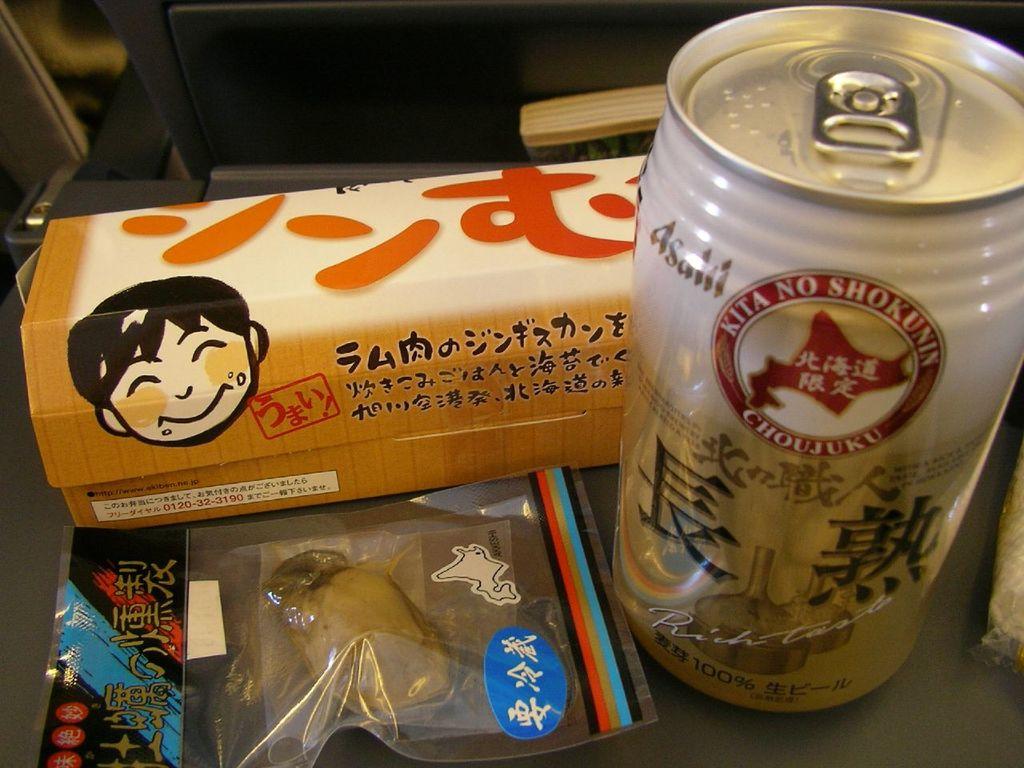What brand is the drink?
Keep it short and to the point. Kita no shokunin. Are these asian treats?
Your answer should be very brief. Yes. 